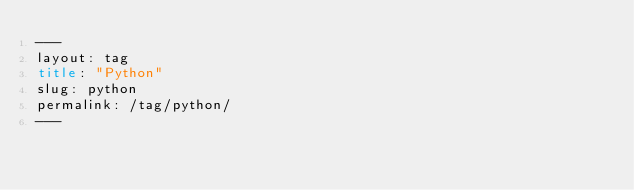<code> <loc_0><loc_0><loc_500><loc_500><_HTML_>---
layout: tag
title: "Python"
slug: python
permalink: /tag/python/
---
</code> 